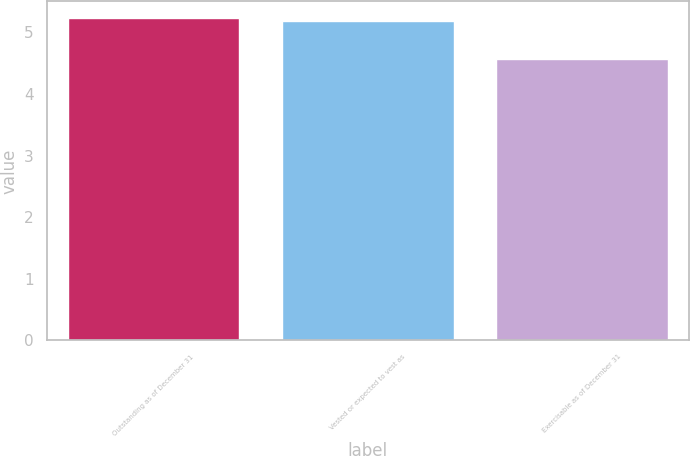Convert chart. <chart><loc_0><loc_0><loc_500><loc_500><bar_chart><fcel>Outstanding as of December 31<fcel>Vested or expected to vest as<fcel>Exercisable as of December 31<nl><fcel>5.24<fcel>5.18<fcel>4.57<nl></chart> 